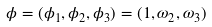Convert formula to latex. <formula><loc_0><loc_0><loc_500><loc_500>\phi = ( \phi _ { 1 } , \phi _ { 2 } , \phi _ { 3 } ) = ( 1 , \omega _ { 2 } , \omega _ { 3 } )</formula> 